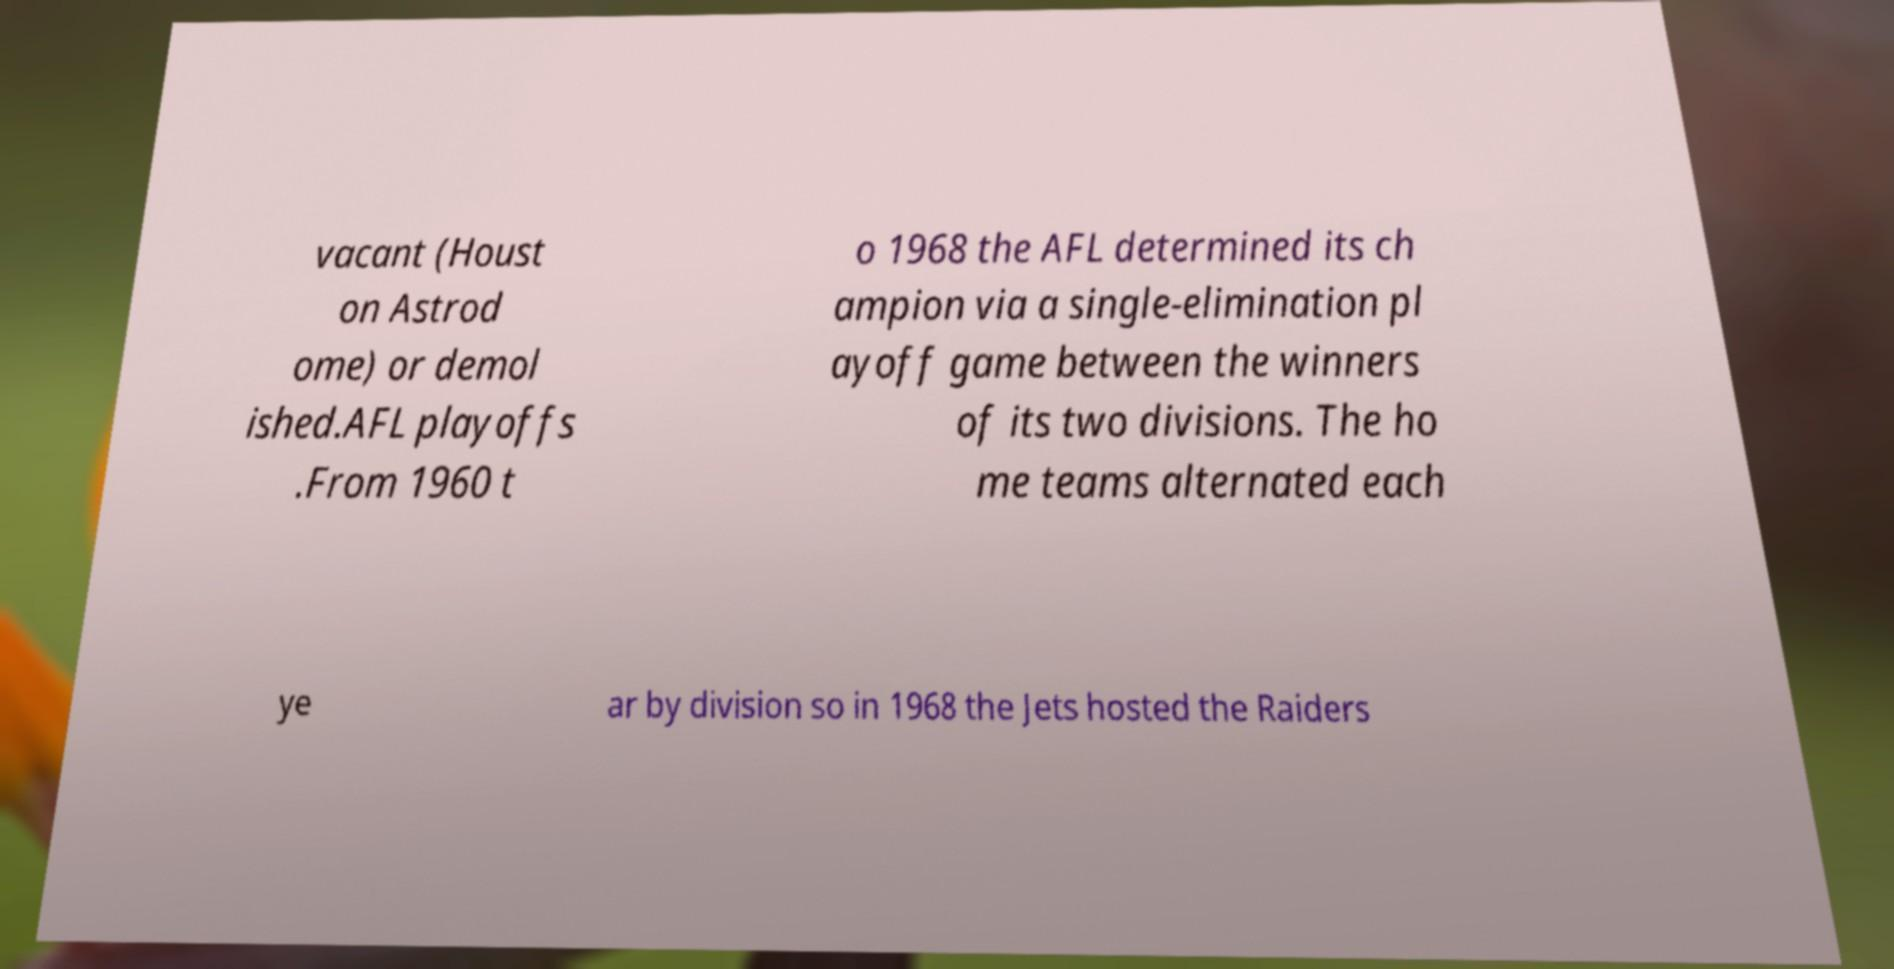Could you assist in decoding the text presented in this image and type it out clearly? vacant (Houst on Astrod ome) or demol ished.AFL playoffs .From 1960 t o 1968 the AFL determined its ch ampion via a single-elimination pl ayoff game between the winners of its two divisions. The ho me teams alternated each ye ar by division so in 1968 the Jets hosted the Raiders 